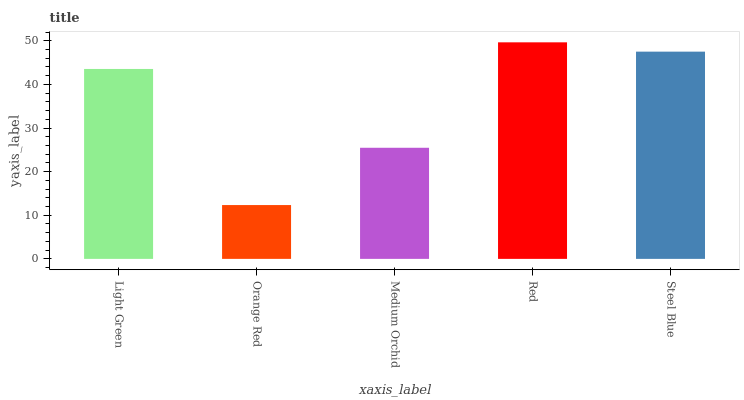Is Orange Red the minimum?
Answer yes or no. Yes. Is Red the maximum?
Answer yes or no. Yes. Is Medium Orchid the minimum?
Answer yes or no. No. Is Medium Orchid the maximum?
Answer yes or no. No. Is Medium Orchid greater than Orange Red?
Answer yes or no. Yes. Is Orange Red less than Medium Orchid?
Answer yes or no. Yes. Is Orange Red greater than Medium Orchid?
Answer yes or no. No. Is Medium Orchid less than Orange Red?
Answer yes or no. No. Is Light Green the high median?
Answer yes or no. Yes. Is Light Green the low median?
Answer yes or no. Yes. Is Medium Orchid the high median?
Answer yes or no. No. Is Medium Orchid the low median?
Answer yes or no. No. 